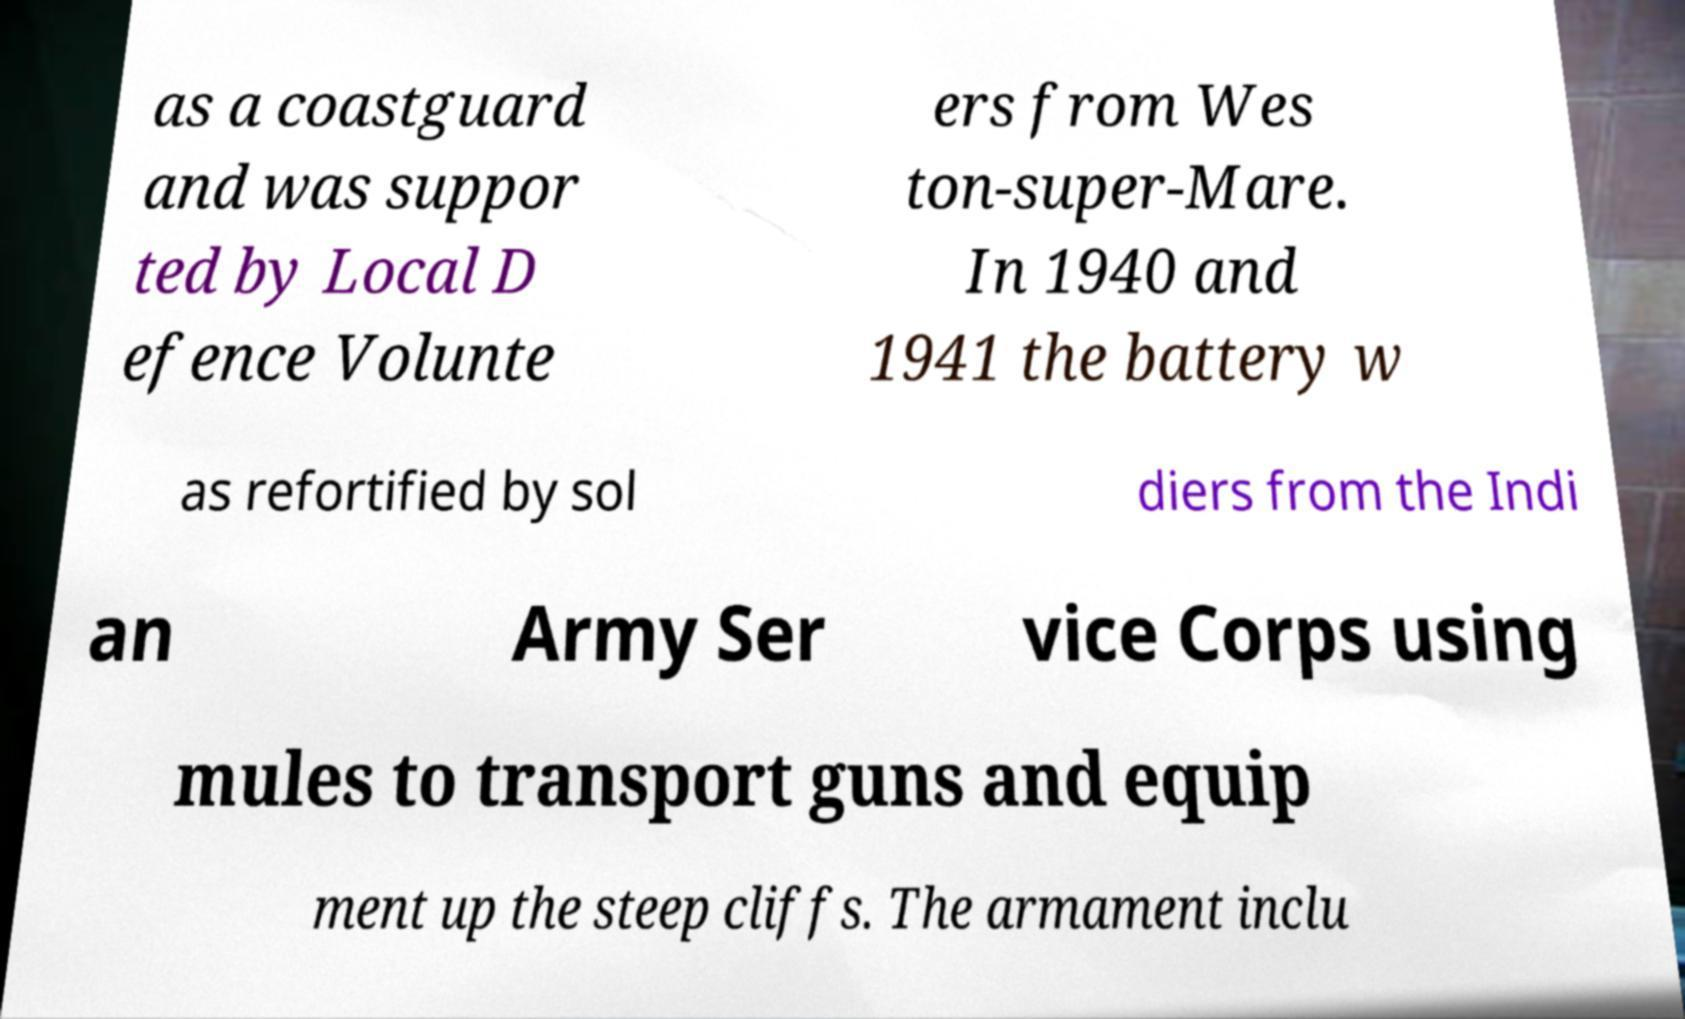For documentation purposes, I need the text within this image transcribed. Could you provide that? as a coastguard and was suppor ted by Local D efence Volunte ers from Wes ton-super-Mare. In 1940 and 1941 the battery w as refortified by sol diers from the Indi an Army Ser vice Corps using mules to transport guns and equip ment up the steep cliffs. The armament inclu 